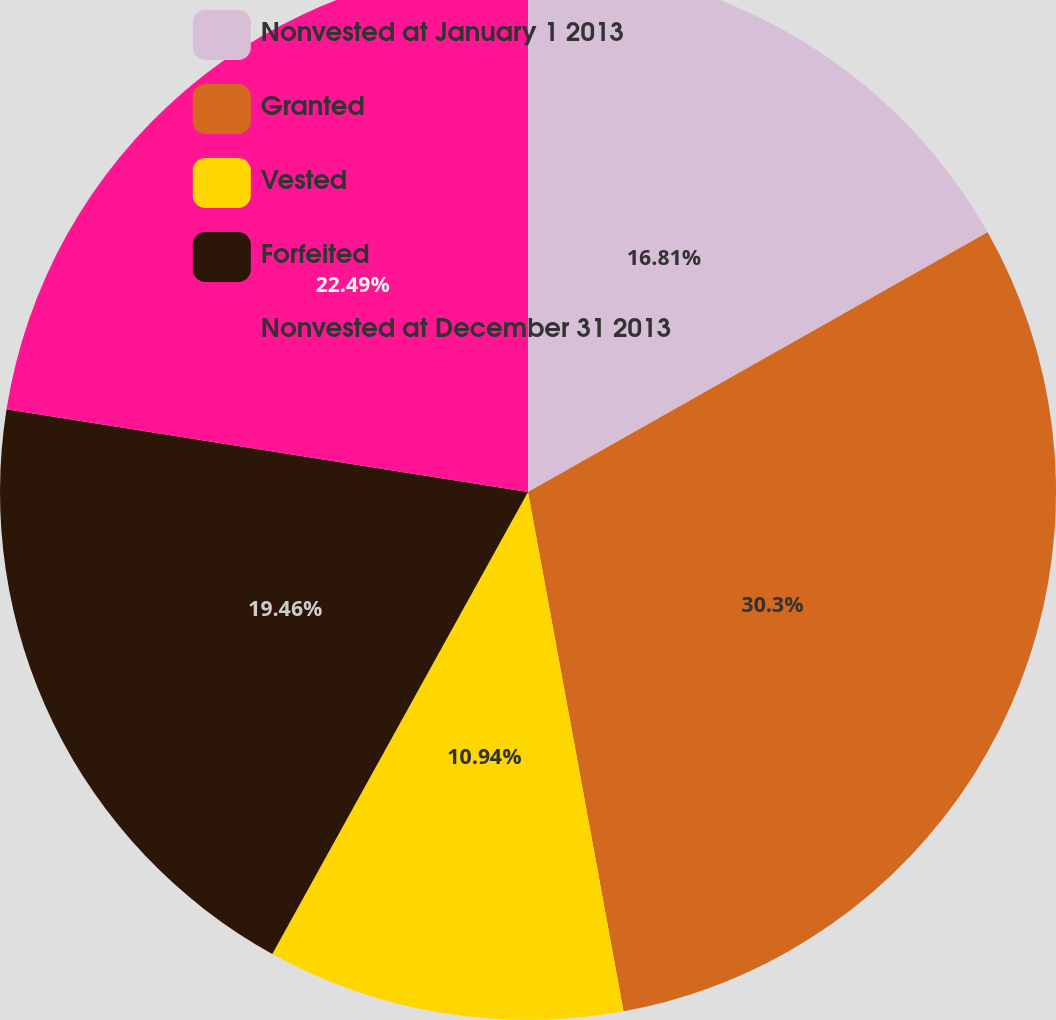Convert chart. <chart><loc_0><loc_0><loc_500><loc_500><pie_chart><fcel>Nonvested at January 1 2013<fcel>Granted<fcel>Vested<fcel>Forfeited<fcel>Nonvested at December 31 2013<nl><fcel>16.81%<fcel>30.29%<fcel>10.94%<fcel>19.46%<fcel>22.49%<nl></chart> 